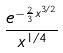Convert formula to latex. <formula><loc_0><loc_0><loc_500><loc_500>\frac { e ^ { - \frac { 2 } { 3 } x ^ { 3 / 2 } } } { x ^ { 1 / 4 } }</formula> 